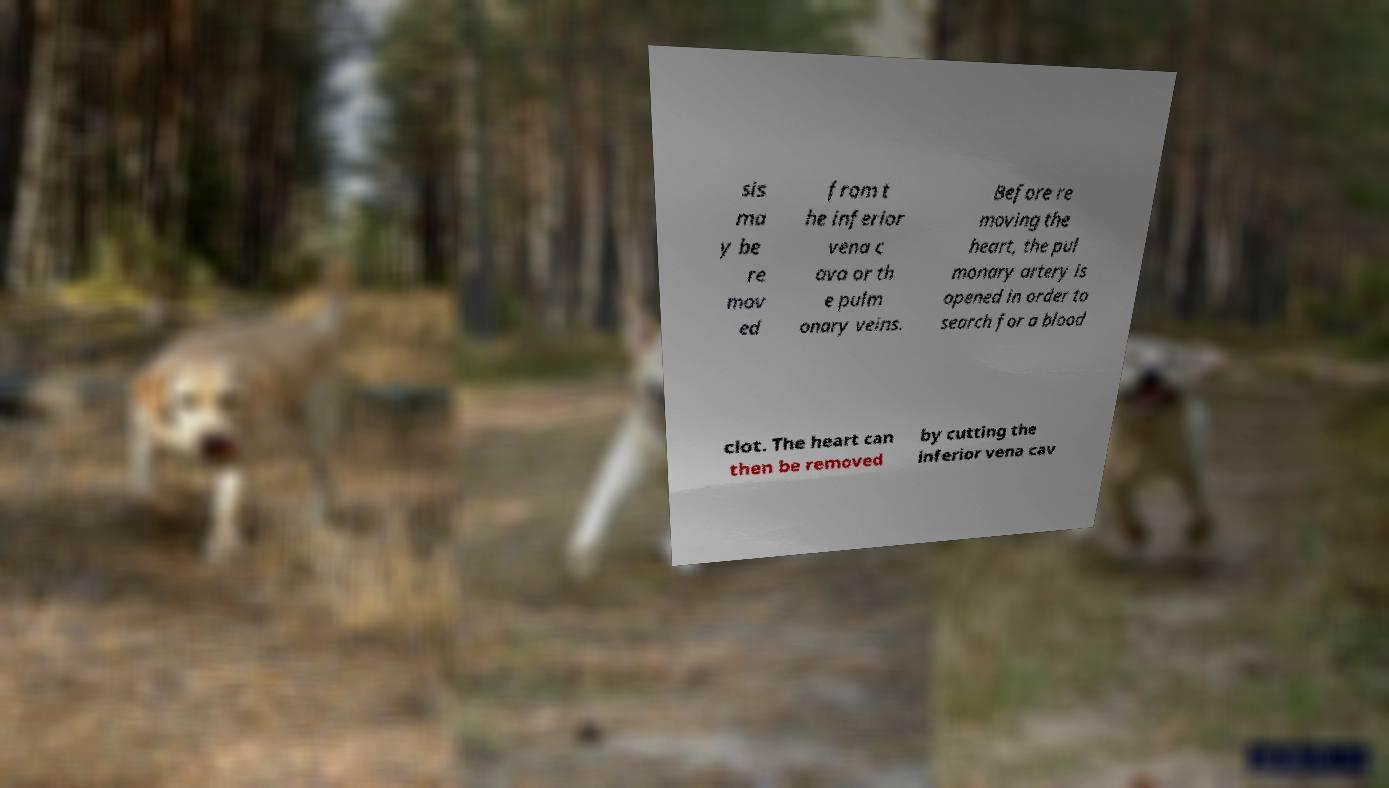Please read and relay the text visible in this image. What does it say? sis ma y be re mov ed from t he inferior vena c ava or th e pulm onary veins. Before re moving the heart, the pul monary artery is opened in order to search for a blood clot. The heart can then be removed by cutting the inferior vena cav 